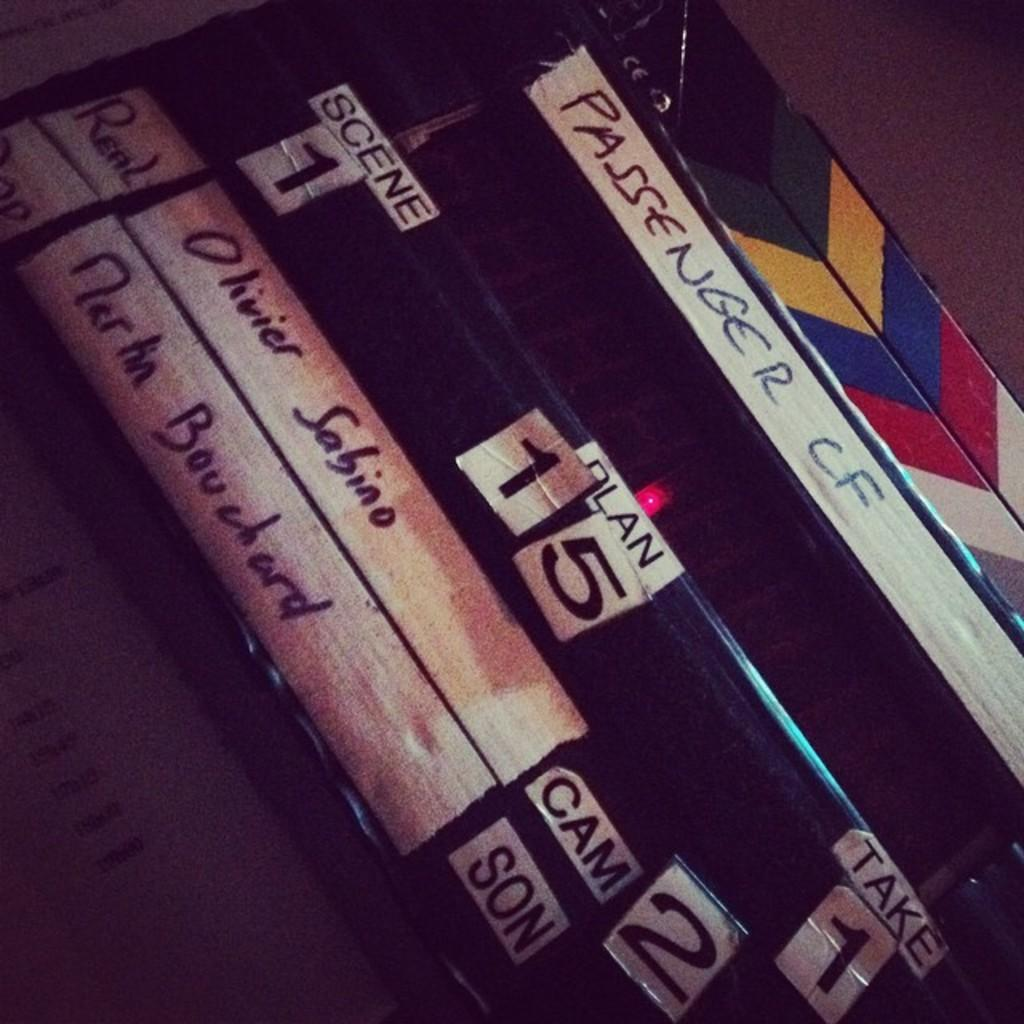<image>
Give a short and clear explanation of the subsequent image. A stack of video cassettes, the top one is labeled Passenger CF. 